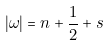<formula> <loc_0><loc_0><loc_500><loc_500>| \omega | = n + \frac { 1 } { 2 } + s</formula> 